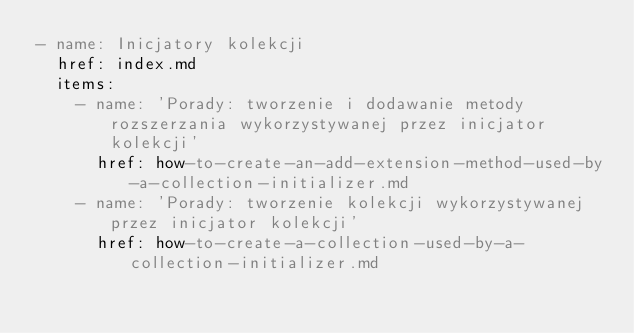Convert code to text. <code><loc_0><loc_0><loc_500><loc_500><_YAML_>- name: Inicjatory kolekcji
  href: index.md
  items:
    - name: 'Porady: tworzenie i dodawanie metody rozszerzania wykorzystywanej przez inicjator kolekcji'
      href: how-to-create-an-add-extension-method-used-by-a-collection-initializer.md
    - name: 'Porady: tworzenie kolekcji wykorzystywanej przez inicjator kolekcji'
      href: how-to-create-a-collection-used-by-a-collection-initializer.md</code> 